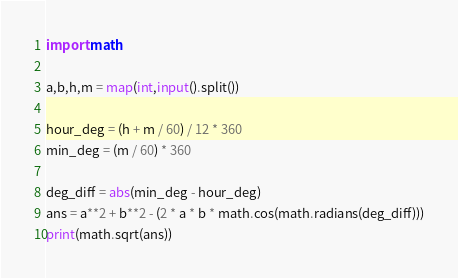Convert code to text. <code><loc_0><loc_0><loc_500><loc_500><_Python_>import math

a,b,h,m = map(int,input().split())

hour_deg = (h + m / 60) / 12 * 360
min_deg = (m / 60) * 360

deg_diff = abs(min_deg - hour_deg)
ans = a**2 + b**2 - (2 * a * b * math.cos(math.radians(deg_diff)))
print(math.sqrt(ans))</code> 